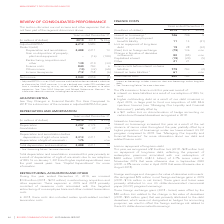From Rogers Communications's financial document, What were the reasons for increase in finance cost in 2019? The document contains multiple relevant values: interest on lease liabilities as a result of our adoption of IFRS 16, higher outstanding debt as a result of our debt issuances in April 2019, in large part to fund our acquisition of 600 MHz spectrum licences (see “Managing Our Liquidity and Financial Resources”); partially offset by, a $21 million loss on discontinuation of hedge accounting on certain bond forward derivatives recognized in 2018.. From the document: "ase in finance costs this year was a result of: • interest on lease liabilities as a result of our adoption of IFRS 16; and • higher outstanding debt ..." Also, What caused the interest on borrowings in 2019? net issuance of senior notes throughout the year. The document states: "borrowings increased this year as a result of the net issuance of senior notes throughout the year, partially offset by a higher proportion of borrowi..." Also, What was the loss on repayment of long-term debt in 2019? According to the financial document, $19 million. The relevant text states: "yment of long-term debt This year, we recognized a $19 million loss (2018 – $28 million loss) on repayment of long-term debt, reflecting the payment of redemption..." Also, can you calculate: What was the increase / (decrease) in Interest on borrowings from 2018 to 2019? Based on the calculation: 746 - 709, the result is 37 (in millions). This is based on the information: "Interest on borrowings 1 746 709 5 Interest on post-employment benefits liability 11 14 (21) Loss on repayment of long-term debt 19 Interest on borrowings 1 746 709 5 Interest on post-employment benef..." The key data points involved are: 709, 746. Also, can you calculate: What was the average Interest on post-employment benefits liability? To answer this question, I need to perform calculations using the financial data. The calculation is: (11 + 14) / 2, which equals 12.5 (in millions). This is based on the information: "5 Interest on post-employment benefits liability 11 14 (21) Loss on repayment of long-term debt 19 28 (32) (Gain) loss on foreign exchange (79) 136 n/m Interest on post-employment benefits liability 1..." The key data points involved are: 11, 14. Also, can you calculate: What was the increase / (decrease) in the Finance costs before interest on lease liabilities from 2018 to 2019? Based on the calculation: 779 - 793, the result is -14 (in millions). This is based on the information: "ce costs before interest on lease liabilities 779 793 (2) Interest on lease liabilities 2 61 – n/m inance costs before interest on lease liabilities 779 793 (2) Interest on lease liabilities 2 61 – n/..." The key data points involved are: 779, 793. 